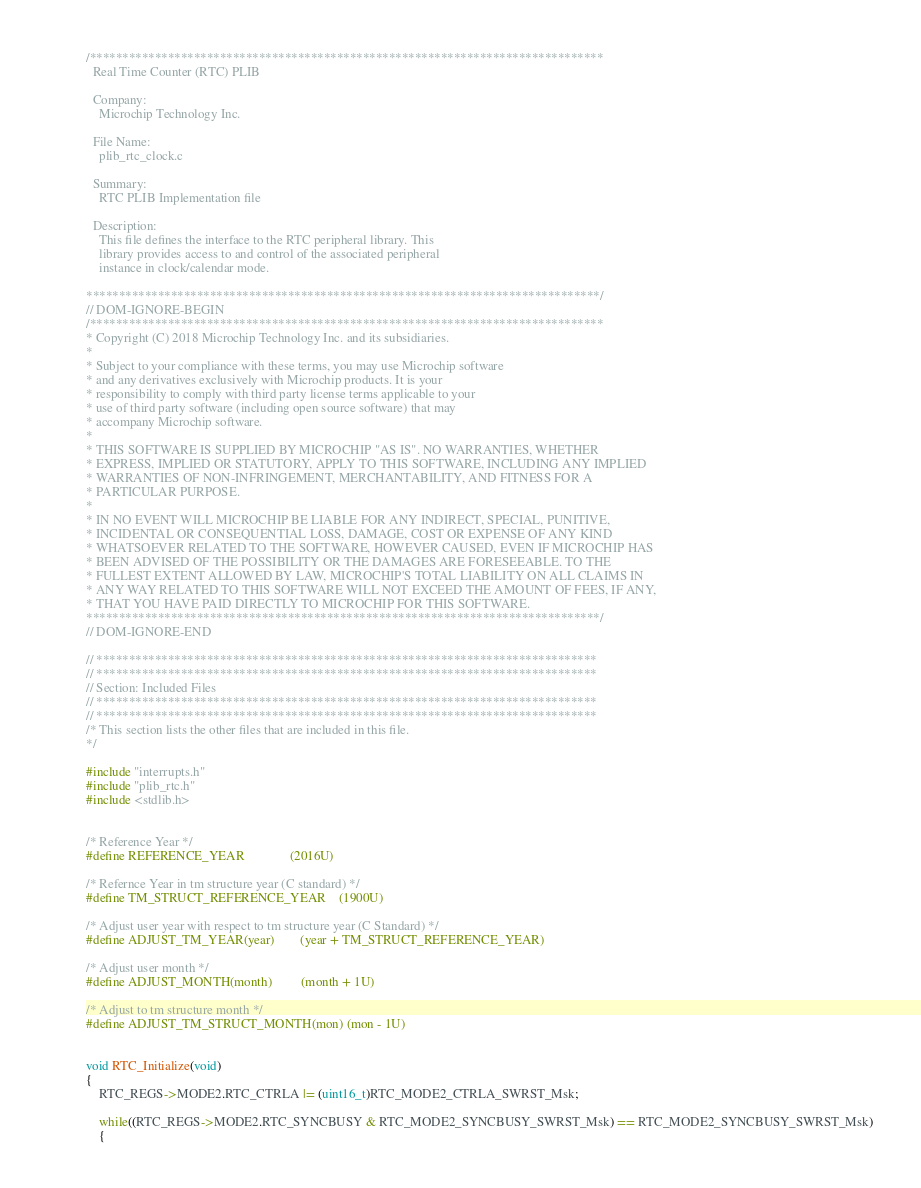Convert code to text. <code><loc_0><loc_0><loc_500><loc_500><_C_>/*******************************************************************************
  Real Time Counter (RTC) PLIB

  Company:
    Microchip Technology Inc.

  File Name:
    plib_rtc_clock.c

  Summary:
    RTC PLIB Implementation file

  Description:
    This file defines the interface to the RTC peripheral library. This
    library provides access to and control of the associated peripheral
    instance in clock/calendar mode.

*******************************************************************************/
// DOM-IGNORE-BEGIN
/*******************************************************************************
* Copyright (C) 2018 Microchip Technology Inc. and its subsidiaries.
*
* Subject to your compliance with these terms, you may use Microchip software
* and any derivatives exclusively with Microchip products. It is your
* responsibility to comply with third party license terms applicable to your
* use of third party software (including open source software) that may
* accompany Microchip software.
*
* THIS SOFTWARE IS SUPPLIED BY MICROCHIP "AS IS". NO WARRANTIES, WHETHER
* EXPRESS, IMPLIED OR STATUTORY, APPLY TO THIS SOFTWARE, INCLUDING ANY IMPLIED
* WARRANTIES OF NON-INFRINGEMENT, MERCHANTABILITY, AND FITNESS FOR A
* PARTICULAR PURPOSE.
*
* IN NO EVENT WILL MICROCHIP BE LIABLE FOR ANY INDIRECT, SPECIAL, PUNITIVE,
* INCIDENTAL OR CONSEQUENTIAL LOSS, DAMAGE, COST OR EXPENSE OF ANY KIND
* WHATSOEVER RELATED TO THE SOFTWARE, HOWEVER CAUSED, EVEN IF MICROCHIP HAS
* BEEN ADVISED OF THE POSSIBILITY OR THE DAMAGES ARE FORESEEABLE. TO THE
* FULLEST EXTENT ALLOWED BY LAW, MICROCHIP'S TOTAL LIABILITY ON ALL CLAIMS IN
* ANY WAY RELATED TO THIS SOFTWARE WILL NOT EXCEED THE AMOUNT OF FEES, IF ANY,
* THAT YOU HAVE PAID DIRECTLY TO MICROCHIP FOR THIS SOFTWARE.
*******************************************************************************/
// DOM-IGNORE-END

// *****************************************************************************
// *****************************************************************************
// Section: Included Files
// *****************************************************************************
// *****************************************************************************
/* This section lists the other files that are included in this file.
*/

#include "interrupts.h"
#include "plib_rtc.h"
#include <stdlib.h>


/* Reference Year */
#define REFERENCE_YEAR              (2016U)

/* Refernce Year in tm structure year (C standard) */
#define TM_STRUCT_REFERENCE_YEAR    (1900U)

/* Adjust user year with respect to tm structure year (C Standard) */
#define ADJUST_TM_YEAR(year)        (year + TM_STRUCT_REFERENCE_YEAR)

/* Adjust user month */
#define ADJUST_MONTH(month)         (month + 1U)

/* Adjust to tm structure month */
#define ADJUST_TM_STRUCT_MONTH(mon) (mon - 1U)


void RTC_Initialize(void)
{
    RTC_REGS->MODE2.RTC_CTRLA |= (uint16_t)RTC_MODE2_CTRLA_SWRST_Msk;

    while((RTC_REGS->MODE2.RTC_SYNCBUSY & RTC_MODE2_SYNCBUSY_SWRST_Msk) == RTC_MODE2_SYNCBUSY_SWRST_Msk)
    {</code> 